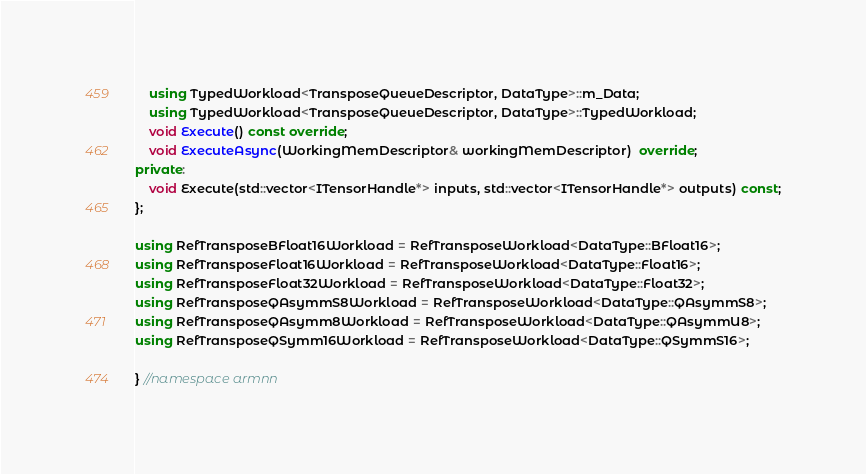<code> <loc_0><loc_0><loc_500><loc_500><_C++_>    using TypedWorkload<TransposeQueueDescriptor, DataType>::m_Data;
    using TypedWorkload<TransposeQueueDescriptor, DataType>::TypedWorkload;
    void Execute() const override;
    void ExecuteAsync(WorkingMemDescriptor& workingMemDescriptor)  override;
private:
    void Execute(std::vector<ITensorHandle*> inputs, std::vector<ITensorHandle*> outputs) const;
};

using RefTransposeBFloat16Workload = RefTransposeWorkload<DataType::BFloat16>;
using RefTransposeFloat16Workload = RefTransposeWorkload<DataType::Float16>;
using RefTransposeFloat32Workload = RefTransposeWorkload<DataType::Float32>;
using RefTransposeQAsymmS8Workload = RefTransposeWorkload<DataType::QAsymmS8>;
using RefTransposeQAsymm8Workload = RefTransposeWorkload<DataType::QAsymmU8>;
using RefTransposeQSymm16Workload = RefTransposeWorkload<DataType::QSymmS16>;

} //namespace armnn</code> 